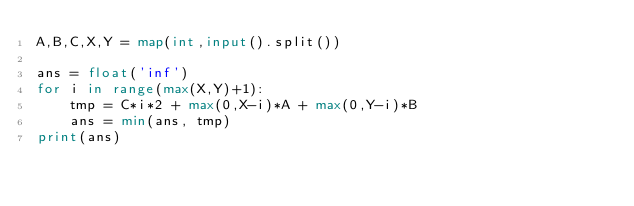Convert code to text. <code><loc_0><loc_0><loc_500><loc_500><_Python_>A,B,C,X,Y = map(int,input().split())
 
ans = float('inf')
for i in range(max(X,Y)+1):
    tmp = C*i*2 + max(0,X-i)*A + max(0,Y-i)*B
    ans = min(ans, tmp)
print(ans)</code> 